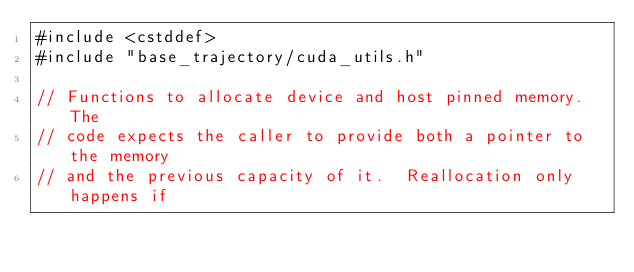<code> <loc_0><loc_0><loc_500><loc_500><_Cuda_>#include <cstddef>
#include "base_trajectory/cuda_utils.h"

// Functions to allocate device and host pinned memory. The
// code expects the caller to provide both a pointer to the memory
// and the previous capacity of it.  Reallocation only happens if</code> 